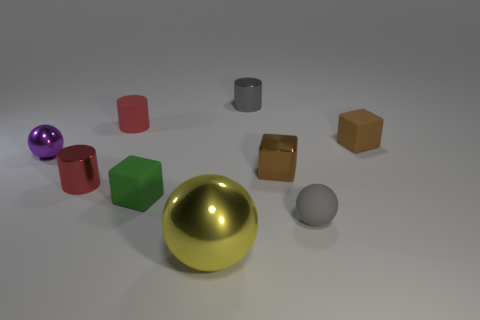Add 1 tiny green blocks. How many objects exist? 10 Subtract all blocks. How many objects are left? 6 Subtract 2 blocks. How many blocks are left? 1 Subtract all red cylinders. How many cylinders are left? 1 Subtract all tiny matte blocks. How many blocks are left? 1 Subtract all cyan cylinders. Subtract all red cubes. How many cylinders are left? 3 Subtract all green spheres. How many green cubes are left? 1 Subtract all blue metal things. Subtract all tiny green things. How many objects are left? 8 Add 8 large things. How many large things are left? 9 Add 7 small red cubes. How many small red cubes exist? 7 